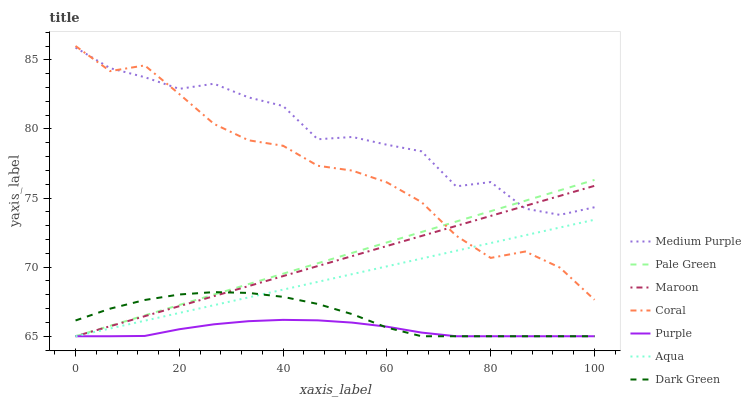Does Purple have the minimum area under the curve?
Answer yes or no. Yes. Does Medium Purple have the maximum area under the curve?
Answer yes or no. Yes. Does Coral have the minimum area under the curve?
Answer yes or no. No. Does Coral have the maximum area under the curve?
Answer yes or no. No. Is Maroon the smoothest?
Answer yes or no. Yes. Is Medium Purple the roughest?
Answer yes or no. Yes. Is Coral the smoothest?
Answer yes or no. No. Is Coral the roughest?
Answer yes or no. No. Does Purple have the lowest value?
Answer yes or no. Yes. Does Coral have the lowest value?
Answer yes or no. No. Does Coral have the highest value?
Answer yes or no. Yes. Does Aqua have the highest value?
Answer yes or no. No. Is Dark Green less than Medium Purple?
Answer yes or no. Yes. Is Medium Purple greater than Dark Green?
Answer yes or no. Yes. Does Aqua intersect Maroon?
Answer yes or no. Yes. Is Aqua less than Maroon?
Answer yes or no. No. Is Aqua greater than Maroon?
Answer yes or no. No. Does Dark Green intersect Medium Purple?
Answer yes or no. No. 